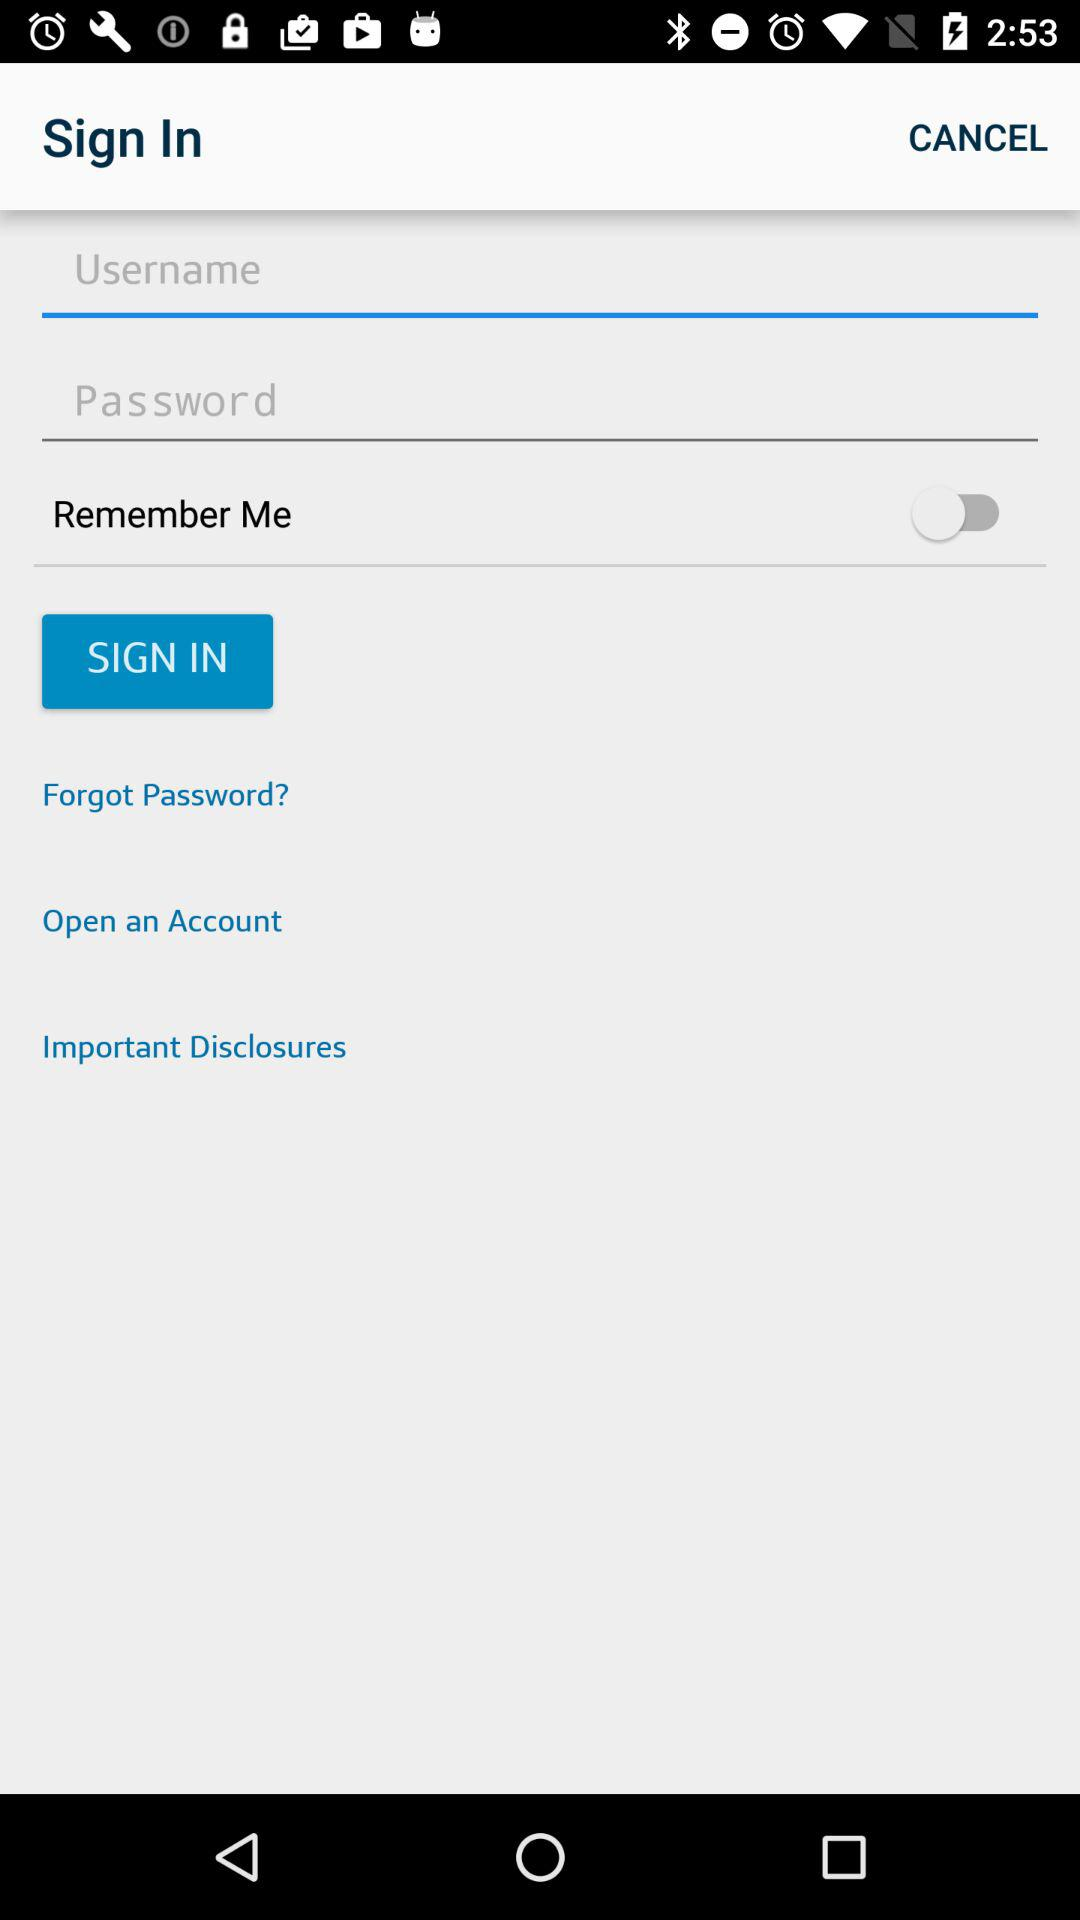What is the status of "Remember Me"? The status is "off". 